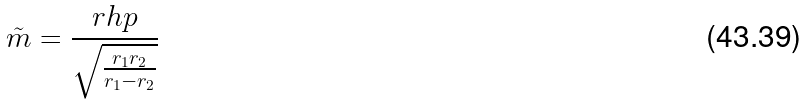Convert formula to latex. <formula><loc_0><loc_0><loc_500><loc_500>\tilde { m } = \frac { r h p } { \sqrt { \frac { r _ { 1 } r _ { 2 } } { r _ { 1 } - r _ { 2 } } } }</formula> 